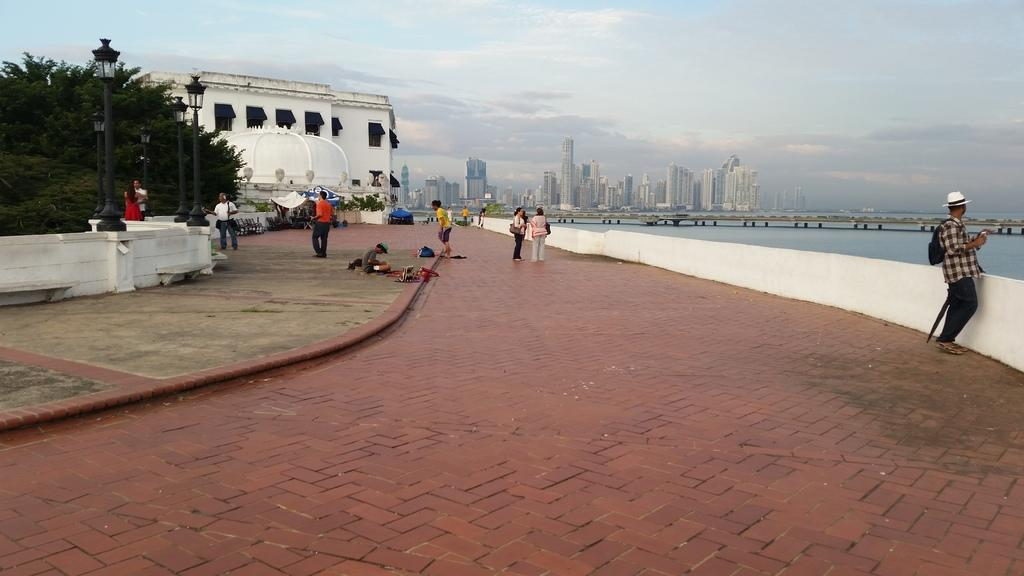How many people are in the image? There is a group of people in the image, but the exact number cannot be determined from the provided facts. What is the primary setting of the image? The image features water, a bridge, buildings, poles, lights, trees, and the sky, suggesting an outdoor urban environment. What type of structures are present in the image? There are buildings and a bridge visible in the image. What can be seen in the background of the image? The sky is visible in the background of the image. What type of instrument is being played by the person on the bike in the image? There is no person on a bike present in the image, and therefore no such activity or instrument can be observed. 